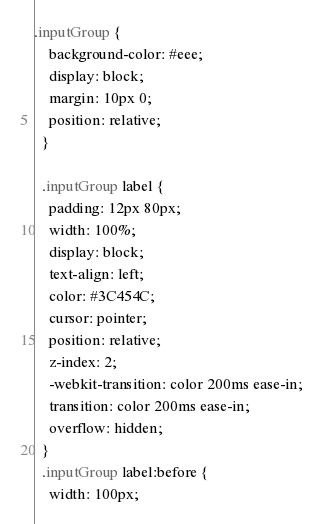<code> <loc_0><loc_0><loc_500><loc_500><_CSS_>.inputGroup {
    background-color: #eee;
    display: block;
    margin: 10px 0;
    position: relative;
  }

  .inputGroup label {
    padding: 12px 80px;
    width: 100%;
    display: block;
    text-align: left;
    color: #3C454C;
    cursor: pointer;
    position: relative;
    z-index: 2;
    -webkit-transition: color 200ms ease-in;
    transition: color 200ms ease-in;
    overflow: hidden;
  }
  .inputGroup label:before {
    width: 100px;</code> 